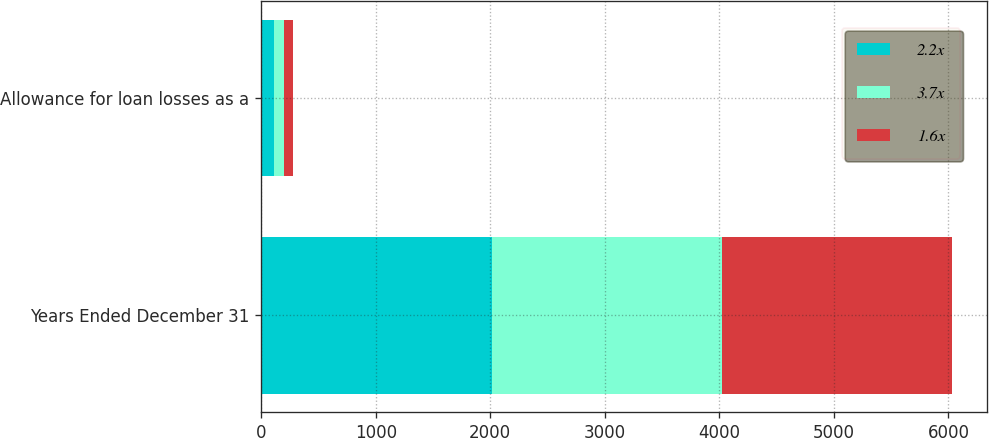<chart> <loc_0><loc_0><loc_500><loc_500><stacked_bar_chart><ecel><fcel>Years Ended December 31<fcel>Allowance for loan losses as a<nl><fcel>2.2x<fcel>2012<fcel>116<nl><fcel>3.7x<fcel>2011<fcel>82<nl><fcel>1.6x<fcel>2010<fcel>80<nl></chart> 